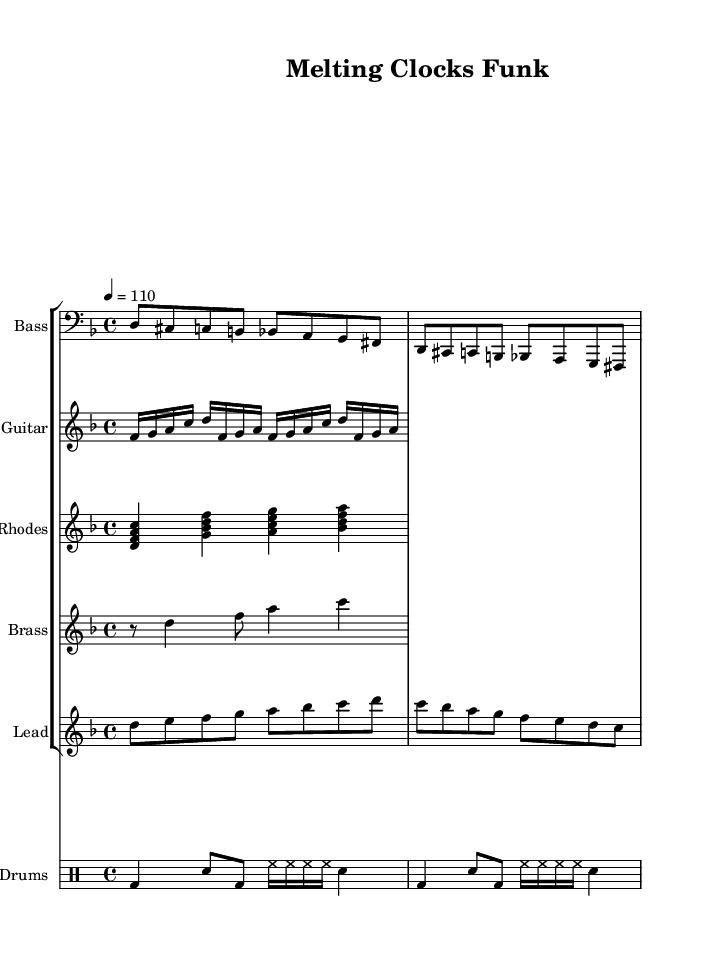What is the key signature of this music? The key signature is D minor, which has one flat (B flat) indicated on the staff.
Answer: D minor What is the time signature of this music? The time signature is 4/4, which is shown at the beginning of the score and indicates that there are four beats in each measure.
Answer: 4/4 What is the tempo marking of this composition? The tempo marking indicates a speed of quarter note equals 110 beats per minute, which is specified at the beginning.
Answer: 110 What are the instruments included in this score? The instruments are Bass, Guitar, Rhodes, Brass, Lead, and Drums, as indicated by the staff names above each section of the music.
Answer: Bass, Guitar, Rhodes, Brass, Lead, Drums Which section uses a sixteenth-note rhythm prominently? The Guitar section utilizes a sixteenth-note rhythm in the riff, which is visually indicated by the grouping of sixteenth notes in that staff.
Answer: Guitar How many measures are in the bass line? The bass line consists of two measures as indicated by the separation into groups corresponding to each measure, counting the beats per measure.
Answer: 2 What is the primary chord used in the Rhodes pattern? The primary chord in the Rhodes pattern is D minor, which is represented by the notes D, F, and A in the first chord shown.
Answer: D minor 